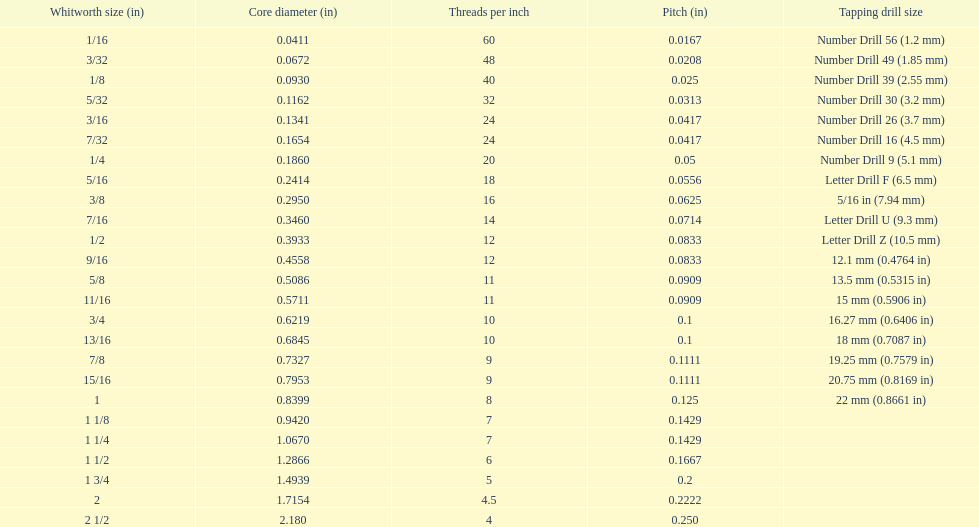What is the total of the first two core diameters? 0.1083. 